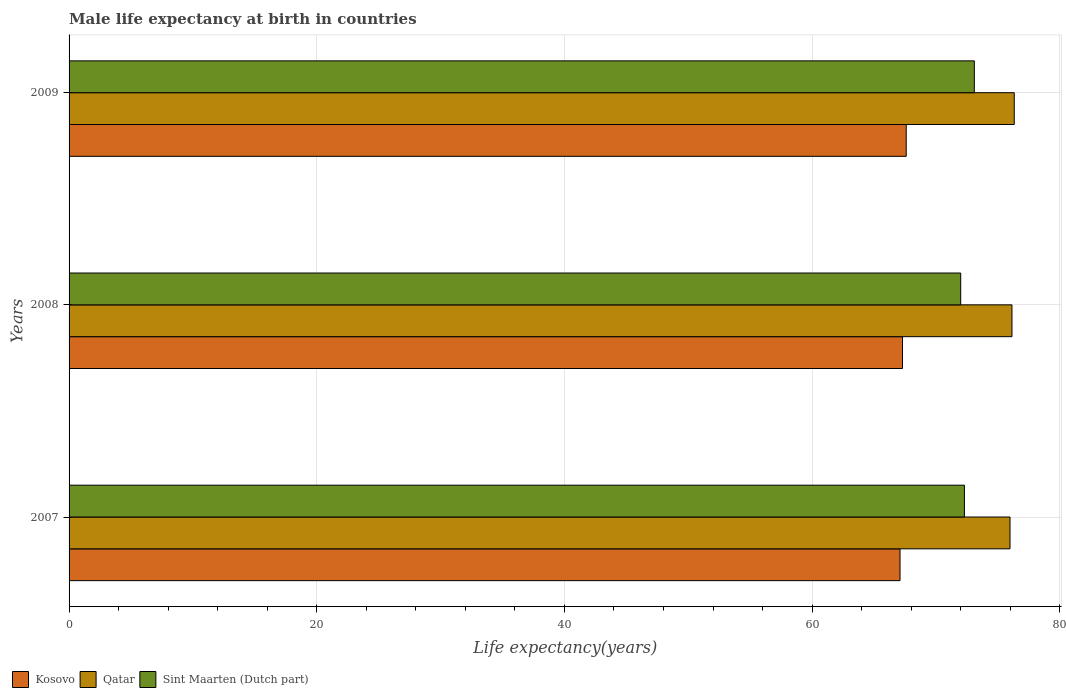How many different coloured bars are there?
Provide a succinct answer. 3. How many groups of bars are there?
Keep it short and to the point. 3. How many bars are there on the 3rd tick from the top?
Make the answer very short. 3. How many bars are there on the 3rd tick from the bottom?
Offer a terse response. 3. What is the label of the 3rd group of bars from the top?
Give a very brief answer. 2007. What is the male life expectancy at birth in Qatar in 2008?
Offer a very short reply. 76.14. Across all years, what is the maximum male life expectancy at birth in Qatar?
Ensure brevity in your answer.  76.32. Across all years, what is the minimum male life expectancy at birth in Qatar?
Your response must be concise. 75.98. In which year was the male life expectancy at birth in Kosovo maximum?
Your answer should be compact. 2009. In which year was the male life expectancy at birth in Sint Maarten (Dutch part) minimum?
Offer a very short reply. 2008. What is the total male life expectancy at birth in Kosovo in the graph?
Make the answer very short. 202. What is the difference between the male life expectancy at birth in Sint Maarten (Dutch part) in 2007 and that in 2009?
Offer a terse response. -0.8. What is the difference between the male life expectancy at birth in Sint Maarten (Dutch part) in 2009 and the male life expectancy at birth in Qatar in 2008?
Offer a terse response. -3.04. What is the average male life expectancy at birth in Qatar per year?
Ensure brevity in your answer.  76.15. In the year 2007, what is the difference between the male life expectancy at birth in Sint Maarten (Dutch part) and male life expectancy at birth in Qatar?
Make the answer very short. -3.68. What is the ratio of the male life expectancy at birth in Sint Maarten (Dutch part) in 2008 to that in 2009?
Provide a short and direct response. 0.98. Is the male life expectancy at birth in Sint Maarten (Dutch part) in 2007 less than that in 2009?
Your response must be concise. Yes. Is the difference between the male life expectancy at birth in Sint Maarten (Dutch part) in 2007 and 2009 greater than the difference between the male life expectancy at birth in Qatar in 2007 and 2009?
Offer a very short reply. No. What is the difference between the highest and the second highest male life expectancy at birth in Sint Maarten (Dutch part)?
Your answer should be very brief. 0.8. What is the difference between the highest and the lowest male life expectancy at birth in Sint Maarten (Dutch part)?
Provide a succinct answer. 1.1. In how many years, is the male life expectancy at birth in Qatar greater than the average male life expectancy at birth in Qatar taken over all years?
Ensure brevity in your answer.  1. Is the sum of the male life expectancy at birth in Qatar in 2008 and 2009 greater than the maximum male life expectancy at birth in Kosovo across all years?
Offer a terse response. Yes. What does the 1st bar from the top in 2007 represents?
Provide a succinct answer. Sint Maarten (Dutch part). What does the 3rd bar from the bottom in 2008 represents?
Make the answer very short. Sint Maarten (Dutch part). How many bars are there?
Your response must be concise. 9. Are all the bars in the graph horizontal?
Your response must be concise. Yes. Does the graph contain any zero values?
Make the answer very short. No. Does the graph contain grids?
Ensure brevity in your answer.  Yes. How are the legend labels stacked?
Your answer should be compact. Horizontal. What is the title of the graph?
Keep it short and to the point. Male life expectancy at birth in countries. Does "Macao" appear as one of the legend labels in the graph?
Offer a very short reply. No. What is the label or title of the X-axis?
Give a very brief answer. Life expectancy(years). What is the label or title of the Y-axis?
Provide a succinct answer. Years. What is the Life expectancy(years) in Kosovo in 2007?
Provide a short and direct response. 67.1. What is the Life expectancy(years) of Qatar in 2007?
Your answer should be very brief. 75.98. What is the Life expectancy(years) in Sint Maarten (Dutch part) in 2007?
Your answer should be very brief. 72.3. What is the Life expectancy(years) in Kosovo in 2008?
Make the answer very short. 67.3. What is the Life expectancy(years) of Qatar in 2008?
Your answer should be very brief. 76.14. What is the Life expectancy(years) of Sint Maarten (Dutch part) in 2008?
Your answer should be compact. 72. What is the Life expectancy(years) of Kosovo in 2009?
Your answer should be compact. 67.6. What is the Life expectancy(years) in Qatar in 2009?
Keep it short and to the point. 76.32. What is the Life expectancy(years) of Sint Maarten (Dutch part) in 2009?
Your answer should be compact. 73.1. Across all years, what is the maximum Life expectancy(years) of Kosovo?
Provide a succinct answer. 67.6. Across all years, what is the maximum Life expectancy(years) in Qatar?
Provide a short and direct response. 76.32. Across all years, what is the maximum Life expectancy(years) of Sint Maarten (Dutch part)?
Offer a very short reply. 73.1. Across all years, what is the minimum Life expectancy(years) in Kosovo?
Offer a terse response. 67.1. Across all years, what is the minimum Life expectancy(years) in Qatar?
Your answer should be compact. 75.98. Across all years, what is the minimum Life expectancy(years) of Sint Maarten (Dutch part)?
Ensure brevity in your answer.  72. What is the total Life expectancy(years) in Kosovo in the graph?
Give a very brief answer. 202. What is the total Life expectancy(years) of Qatar in the graph?
Keep it short and to the point. 228.44. What is the total Life expectancy(years) in Sint Maarten (Dutch part) in the graph?
Offer a very short reply. 217.4. What is the difference between the Life expectancy(years) in Kosovo in 2007 and that in 2008?
Offer a terse response. -0.2. What is the difference between the Life expectancy(years) of Qatar in 2007 and that in 2008?
Your answer should be compact. -0.16. What is the difference between the Life expectancy(years) in Kosovo in 2007 and that in 2009?
Give a very brief answer. -0.5. What is the difference between the Life expectancy(years) in Qatar in 2007 and that in 2009?
Keep it short and to the point. -0.34. What is the difference between the Life expectancy(years) in Sint Maarten (Dutch part) in 2007 and that in 2009?
Your response must be concise. -0.8. What is the difference between the Life expectancy(years) of Kosovo in 2008 and that in 2009?
Your answer should be very brief. -0.3. What is the difference between the Life expectancy(years) of Qatar in 2008 and that in 2009?
Offer a terse response. -0.18. What is the difference between the Life expectancy(years) of Sint Maarten (Dutch part) in 2008 and that in 2009?
Your answer should be compact. -1.1. What is the difference between the Life expectancy(years) of Kosovo in 2007 and the Life expectancy(years) of Qatar in 2008?
Provide a succinct answer. -9.04. What is the difference between the Life expectancy(years) of Qatar in 2007 and the Life expectancy(years) of Sint Maarten (Dutch part) in 2008?
Your answer should be compact. 3.98. What is the difference between the Life expectancy(years) in Kosovo in 2007 and the Life expectancy(years) in Qatar in 2009?
Provide a succinct answer. -9.22. What is the difference between the Life expectancy(years) in Qatar in 2007 and the Life expectancy(years) in Sint Maarten (Dutch part) in 2009?
Offer a terse response. 2.88. What is the difference between the Life expectancy(years) of Kosovo in 2008 and the Life expectancy(years) of Qatar in 2009?
Ensure brevity in your answer.  -9.02. What is the difference between the Life expectancy(years) of Qatar in 2008 and the Life expectancy(years) of Sint Maarten (Dutch part) in 2009?
Make the answer very short. 3.04. What is the average Life expectancy(years) of Kosovo per year?
Ensure brevity in your answer.  67.33. What is the average Life expectancy(years) in Qatar per year?
Your answer should be compact. 76.15. What is the average Life expectancy(years) in Sint Maarten (Dutch part) per year?
Provide a short and direct response. 72.47. In the year 2007, what is the difference between the Life expectancy(years) of Kosovo and Life expectancy(years) of Qatar?
Keep it short and to the point. -8.88. In the year 2007, what is the difference between the Life expectancy(years) of Qatar and Life expectancy(years) of Sint Maarten (Dutch part)?
Ensure brevity in your answer.  3.68. In the year 2008, what is the difference between the Life expectancy(years) in Kosovo and Life expectancy(years) in Qatar?
Give a very brief answer. -8.84. In the year 2008, what is the difference between the Life expectancy(years) in Kosovo and Life expectancy(years) in Sint Maarten (Dutch part)?
Make the answer very short. -4.7. In the year 2008, what is the difference between the Life expectancy(years) of Qatar and Life expectancy(years) of Sint Maarten (Dutch part)?
Provide a short and direct response. 4.14. In the year 2009, what is the difference between the Life expectancy(years) in Kosovo and Life expectancy(years) in Qatar?
Ensure brevity in your answer.  -8.72. In the year 2009, what is the difference between the Life expectancy(years) of Kosovo and Life expectancy(years) of Sint Maarten (Dutch part)?
Your answer should be compact. -5.5. In the year 2009, what is the difference between the Life expectancy(years) of Qatar and Life expectancy(years) of Sint Maarten (Dutch part)?
Provide a short and direct response. 3.22. What is the ratio of the Life expectancy(years) of Kosovo in 2007 to that in 2008?
Your response must be concise. 1. What is the ratio of the Life expectancy(years) in Sint Maarten (Dutch part) in 2007 to that in 2008?
Ensure brevity in your answer.  1. What is the ratio of the Life expectancy(years) of Kosovo in 2007 to that in 2009?
Provide a short and direct response. 0.99. What is the ratio of the Life expectancy(years) in Qatar in 2007 to that in 2009?
Your response must be concise. 1. What is the ratio of the Life expectancy(years) of Kosovo in 2008 to that in 2009?
Make the answer very short. 1. What is the ratio of the Life expectancy(years) of Sint Maarten (Dutch part) in 2008 to that in 2009?
Offer a terse response. 0.98. What is the difference between the highest and the second highest Life expectancy(years) of Kosovo?
Your response must be concise. 0.3. What is the difference between the highest and the second highest Life expectancy(years) of Qatar?
Your answer should be compact. 0.18. What is the difference between the highest and the lowest Life expectancy(years) in Qatar?
Ensure brevity in your answer.  0.34. 